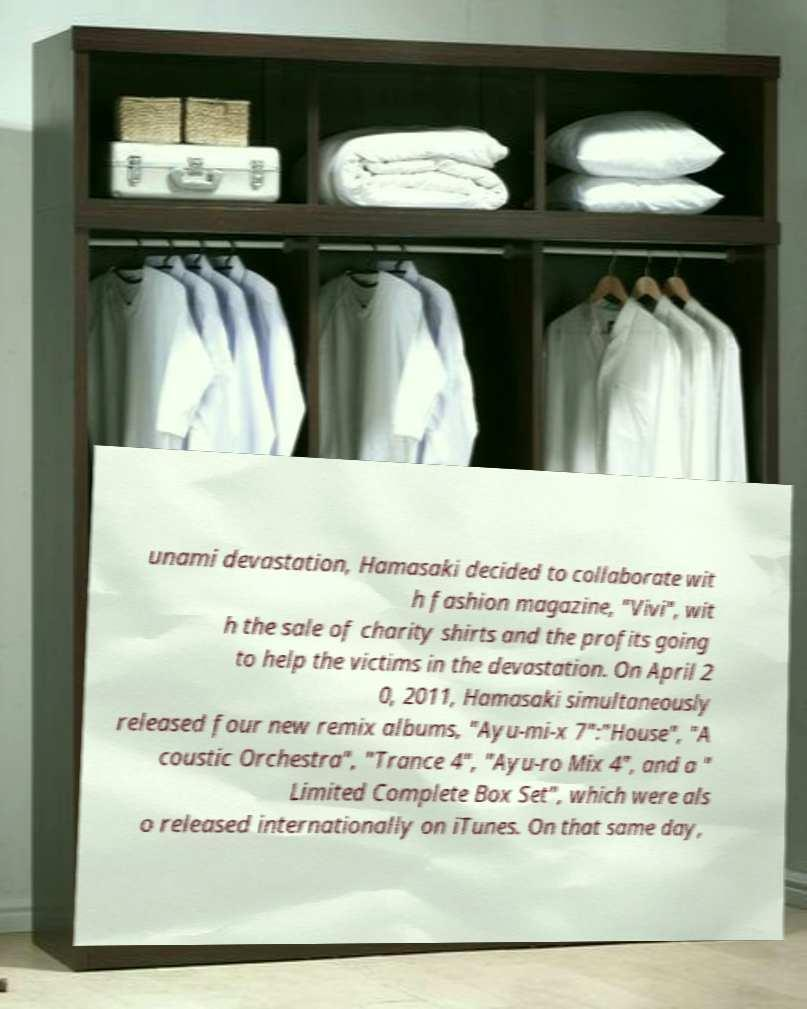For documentation purposes, I need the text within this image transcribed. Could you provide that? unami devastation, Hamasaki decided to collaborate wit h fashion magazine, "Vivi", wit h the sale of charity shirts and the profits going to help the victims in the devastation. On April 2 0, 2011, Hamasaki simultaneously released four new remix albums, "Ayu-mi-x 7":"House", "A coustic Orchestra", "Trance 4", "Ayu-ro Mix 4", and a " Limited Complete Box Set", which were als o released internationally on iTunes. On that same day, 